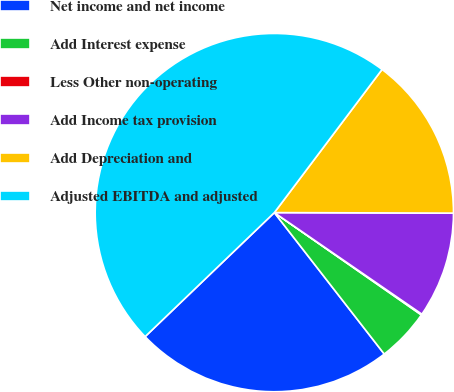Convert chart. <chart><loc_0><loc_0><loc_500><loc_500><pie_chart><fcel>Net income and net income<fcel>Add Interest expense<fcel>Less Other non-operating<fcel>Add Income tax provision<fcel>Add Depreciation and<fcel>Adjusted EBITDA and adjusted<nl><fcel>23.34%<fcel>4.81%<fcel>0.08%<fcel>9.55%<fcel>14.78%<fcel>47.44%<nl></chart> 